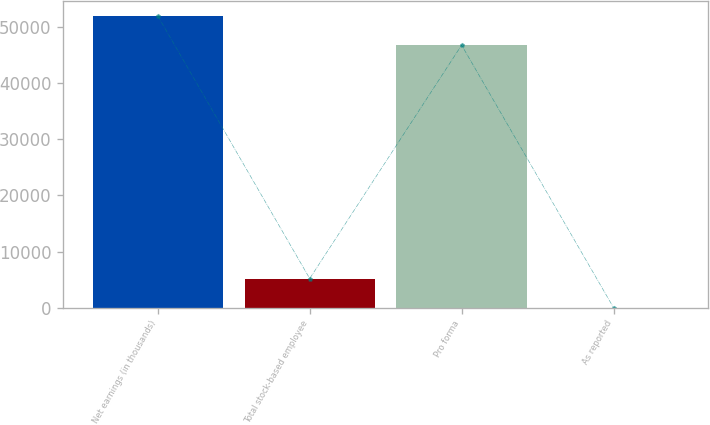Convert chart to OTSL. <chart><loc_0><loc_0><loc_500><loc_500><bar_chart><fcel>Net earnings (in thousands)<fcel>Total stock-based employee<fcel>Pro forma<fcel>As reported<nl><fcel>51989.5<fcel>5182.82<fcel>46808<fcel>1.36<nl></chart> 